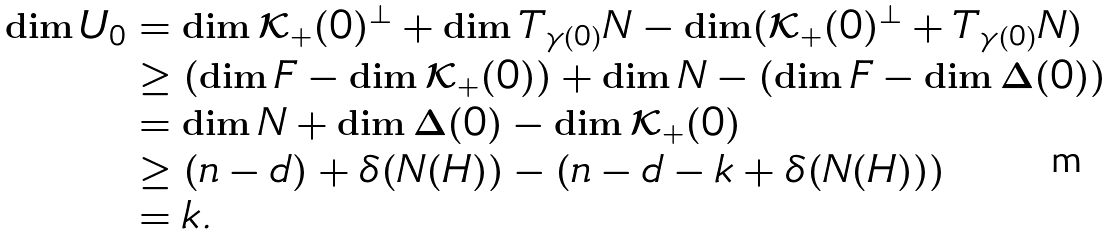<formula> <loc_0><loc_0><loc_500><loc_500>\dim U _ { 0 } & = \dim \mathcal { K } _ { + } ( 0 ) ^ { \perp } + \dim T _ { \gamma ( 0 ) } N - \dim ( \mathcal { K } _ { + } ( 0 ) ^ { \perp } + T _ { \gamma ( 0 ) } N ) \\ & \geq ( \dim F - \dim \mathcal { K } _ { + } ( 0 ) ) + \dim N - \left ( \dim F - \dim \Delta ( 0 ) \right ) \\ & = \dim N + \dim \Delta ( 0 ) - \dim \mathcal { K } _ { + } ( 0 ) \\ & \geq ( n - d ) + \delta ( N ( H ) ) - ( n - d - k + \delta ( N ( H ) ) ) \\ & = k .</formula> 